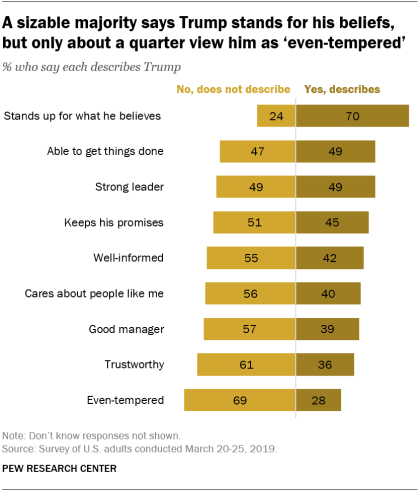Identify some key points in this picture. The value of yellow bars is increasing from top to bottom. The value of the largest bar is 70. 